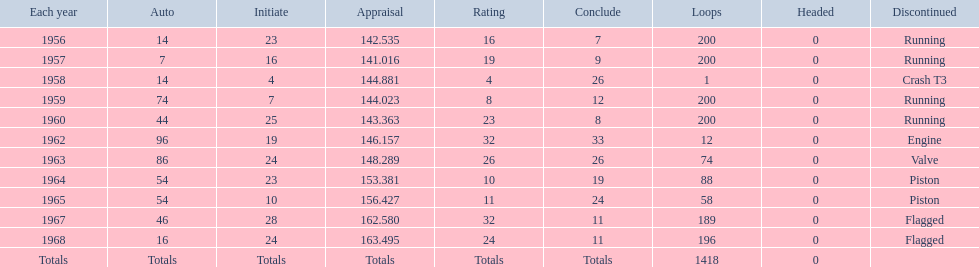What is the larger laps between 1963 or 1968 1968. 